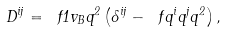Convert formula to latex. <formula><loc_0><loc_0><loc_500><loc_500>D ^ { i j } = \ f { 1 } { v _ { B } q ^ { 2 } } \left ( \delta ^ { i j } - \ f { q ^ { i } q ^ { j } } { q ^ { 2 } } \right ) ,</formula> 